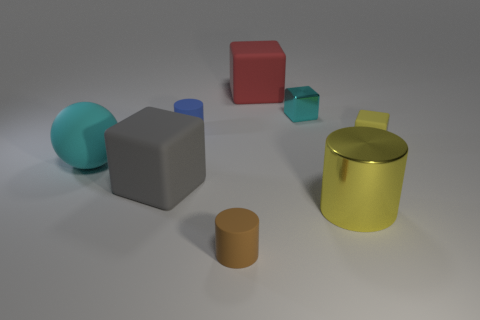Add 1 tiny yellow rubber objects. How many objects exist? 9 Subtract all cylinders. How many objects are left? 5 Add 2 cubes. How many cubes exist? 6 Subtract 1 yellow cylinders. How many objects are left? 7 Subtract all small red cylinders. Subtract all gray matte things. How many objects are left? 7 Add 3 tiny yellow objects. How many tiny yellow objects are left? 4 